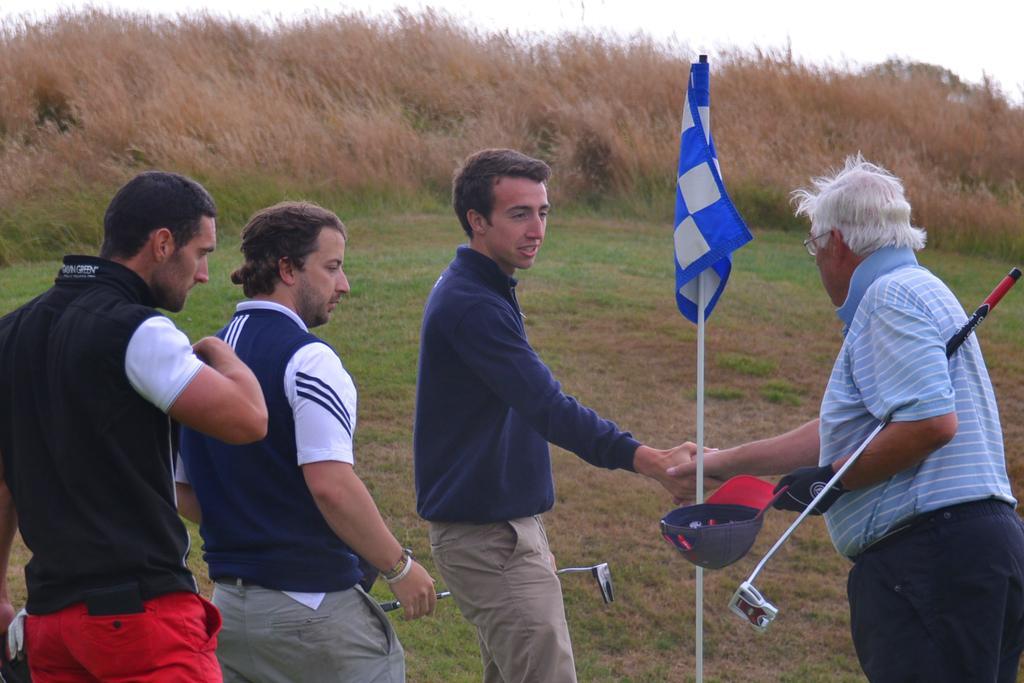Could you give a brief overview of what you see in this image? In this picture, we see four men are standing. The man on the right side is holding a stick and a cap in his hand. He is shaking his hand with the man who is wearing the blue T-shirt. Beside them, we see a flag pole and a flag in white and blue color. At the bottom, we see the grass. There are trees in the background. At the top, we see the sky. 